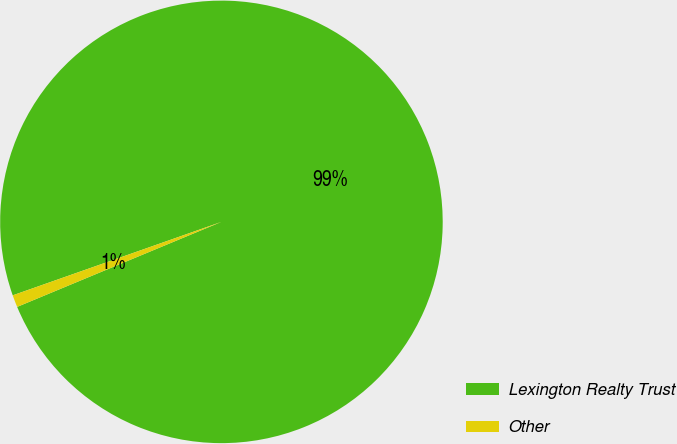Convert chart. <chart><loc_0><loc_0><loc_500><loc_500><pie_chart><fcel>Lexington Realty Trust<fcel>Other<nl><fcel>99.11%<fcel>0.89%<nl></chart> 